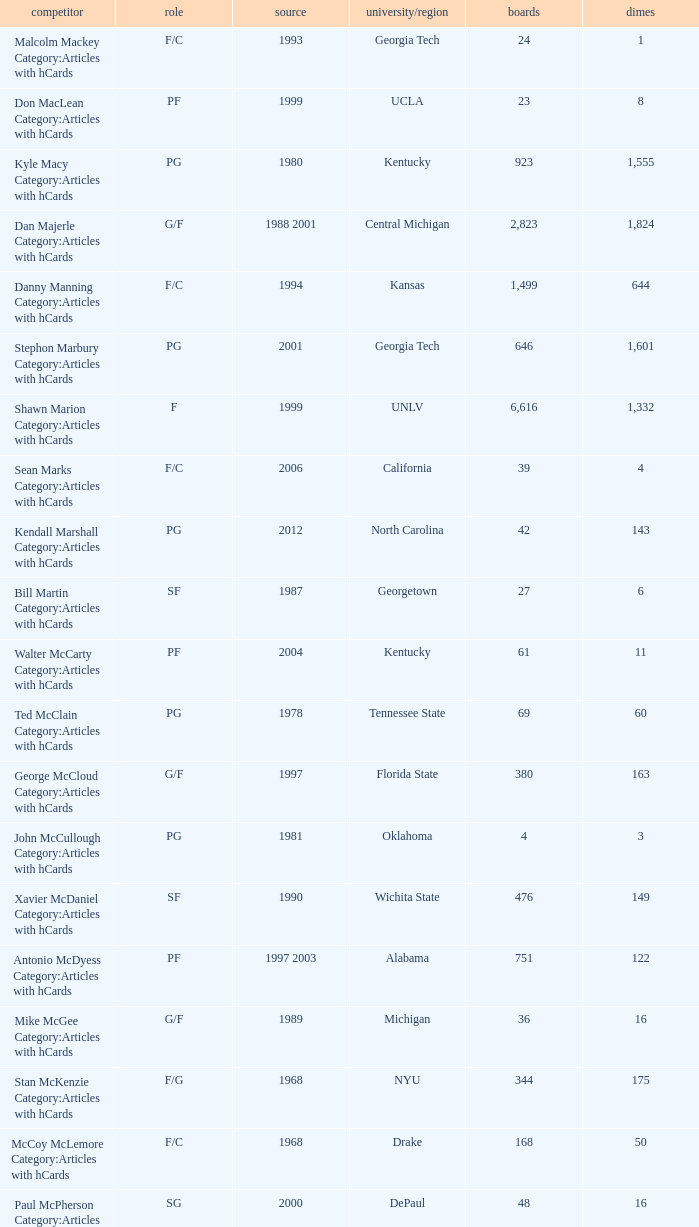Who has the high assists in 2000? 16.0. 